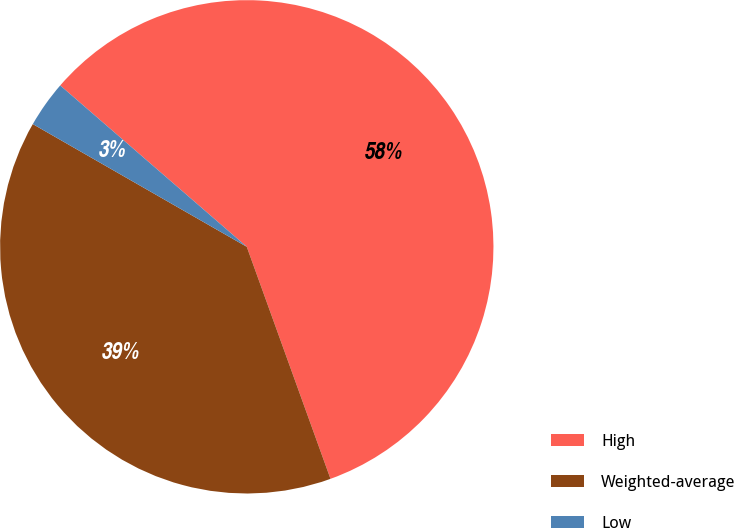Convert chart to OTSL. <chart><loc_0><loc_0><loc_500><loc_500><pie_chart><fcel>High<fcel>Weighted-average<fcel>Low<nl><fcel>58.14%<fcel>38.8%<fcel>3.06%<nl></chart> 